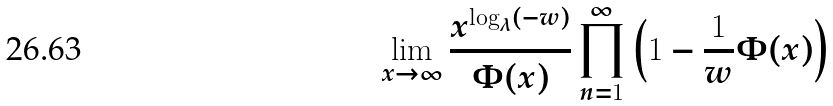Convert formula to latex. <formula><loc_0><loc_0><loc_500><loc_500>\lim _ { x \to \infty } \frac { x ^ { \log _ { \lambda } ( - w ) } } { \Phi ( x ) } \prod _ { n = 1 } ^ { \infty } \left ( 1 - \frac { 1 } { w } \Phi ( x ) \right )</formula> 